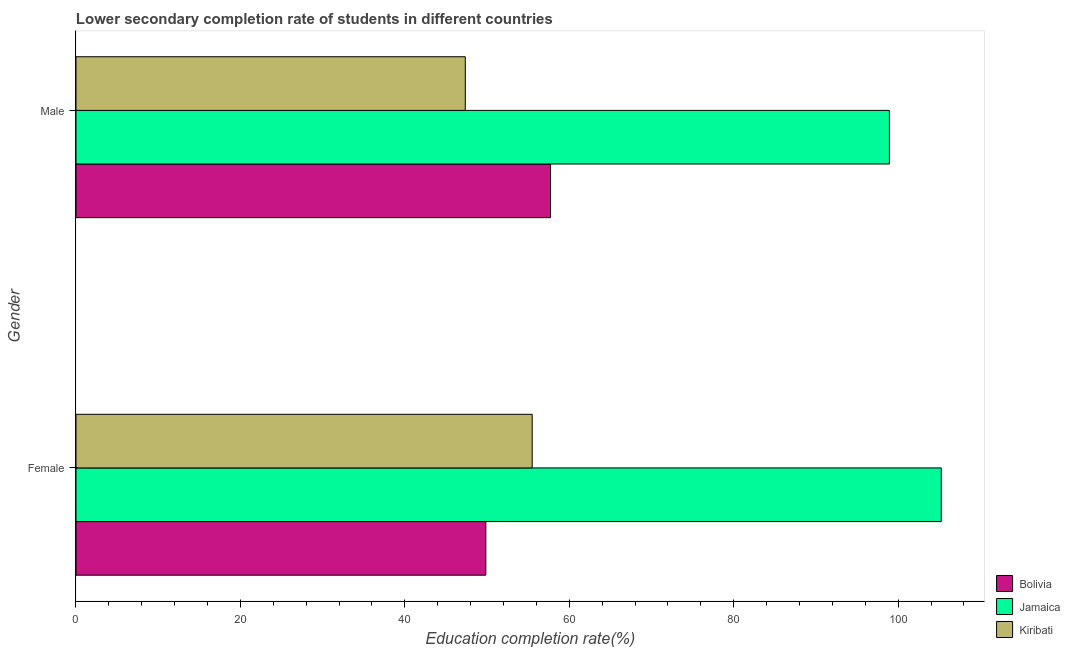How many different coloured bars are there?
Keep it short and to the point. 3. How many groups of bars are there?
Your answer should be very brief. 2. Are the number of bars per tick equal to the number of legend labels?
Your response must be concise. Yes. Are the number of bars on each tick of the Y-axis equal?
Ensure brevity in your answer.  Yes. How many bars are there on the 1st tick from the bottom?
Your answer should be very brief. 3. What is the education completion rate of male students in Kiribati?
Offer a very short reply. 47.35. Across all countries, what is the maximum education completion rate of female students?
Offer a terse response. 105.25. Across all countries, what is the minimum education completion rate of male students?
Give a very brief answer. 47.35. In which country was the education completion rate of male students maximum?
Make the answer very short. Jamaica. What is the total education completion rate of male students in the graph?
Give a very brief answer. 204.01. What is the difference between the education completion rate of male students in Kiribati and that in Bolivia?
Ensure brevity in your answer.  -10.37. What is the difference between the education completion rate of female students in Bolivia and the education completion rate of male students in Kiribati?
Offer a terse response. 2.5. What is the average education completion rate of male students per country?
Your response must be concise. 68. What is the difference between the education completion rate of male students and education completion rate of female students in Kiribati?
Your answer should be compact. -8.14. What is the ratio of the education completion rate of female students in Jamaica to that in Bolivia?
Provide a succinct answer. 2.11. Is the education completion rate of male students in Jamaica less than that in Bolivia?
Your response must be concise. No. In how many countries, is the education completion rate of male students greater than the average education completion rate of male students taken over all countries?
Keep it short and to the point. 1. What does the 1st bar from the bottom in Male represents?
Provide a succinct answer. Bolivia. How many bars are there?
Your answer should be very brief. 6. Are all the bars in the graph horizontal?
Ensure brevity in your answer.  Yes. What is the difference between two consecutive major ticks on the X-axis?
Provide a short and direct response. 20. Are the values on the major ticks of X-axis written in scientific E-notation?
Give a very brief answer. No. Does the graph contain any zero values?
Give a very brief answer. No. Does the graph contain grids?
Ensure brevity in your answer.  No. How many legend labels are there?
Ensure brevity in your answer.  3. What is the title of the graph?
Your response must be concise. Lower secondary completion rate of students in different countries. Does "Tunisia" appear as one of the legend labels in the graph?
Keep it short and to the point. No. What is the label or title of the X-axis?
Offer a very short reply. Education completion rate(%). What is the label or title of the Y-axis?
Your response must be concise. Gender. What is the Education completion rate(%) of Bolivia in Female?
Ensure brevity in your answer.  49.85. What is the Education completion rate(%) of Jamaica in Female?
Offer a terse response. 105.25. What is the Education completion rate(%) in Kiribati in Female?
Provide a succinct answer. 55.49. What is the Education completion rate(%) in Bolivia in Male?
Offer a terse response. 57.72. What is the Education completion rate(%) of Jamaica in Male?
Your answer should be compact. 98.94. What is the Education completion rate(%) in Kiribati in Male?
Make the answer very short. 47.35. Across all Gender, what is the maximum Education completion rate(%) of Bolivia?
Give a very brief answer. 57.72. Across all Gender, what is the maximum Education completion rate(%) in Jamaica?
Give a very brief answer. 105.25. Across all Gender, what is the maximum Education completion rate(%) in Kiribati?
Your answer should be compact. 55.49. Across all Gender, what is the minimum Education completion rate(%) in Bolivia?
Provide a succinct answer. 49.85. Across all Gender, what is the minimum Education completion rate(%) of Jamaica?
Keep it short and to the point. 98.94. Across all Gender, what is the minimum Education completion rate(%) in Kiribati?
Ensure brevity in your answer.  47.35. What is the total Education completion rate(%) in Bolivia in the graph?
Offer a terse response. 107.57. What is the total Education completion rate(%) of Jamaica in the graph?
Your answer should be very brief. 204.19. What is the total Education completion rate(%) in Kiribati in the graph?
Provide a succinct answer. 102.84. What is the difference between the Education completion rate(%) of Bolivia in Female and that in Male?
Offer a very short reply. -7.87. What is the difference between the Education completion rate(%) of Jamaica in Female and that in Male?
Keep it short and to the point. 6.31. What is the difference between the Education completion rate(%) in Kiribati in Female and that in Male?
Give a very brief answer. 8.14. What is the difference between the Education completion rate(%) in Bolivia in Female and the Education completion rate(%) in Jamaica in Male?
Provide a succinct answer. -49.09. What is the difference between the Education completion rate(%) in Bolivia in Female and the Education completion rate(%) in Kiribati in Male?
Your answer should be compact. 2.5. What is the difference between the Education completion rate(%) in Jamaica in Female and the Education completion rate(%) in Kiribati in Male?
Offer a very short reply. 57.9. What is the average Education completion rate(%) in Bolivia per Gender?
Your answer should be very brief. 53.79. What is the average Education completion rate(%) of Jamaica per Gender?
Offer a terse response. 102.09. What is the average Education completion rate(%) in Kiribati per Gender?
Make the answer very short. 51.42. What is the difference between the Education completion rate(%) in Bolivia and Education completion rate(%) in Jamaica in Female?
Keep it short and to the point. -55.4. What is the difference between the Education completion rate(%) of Bolivia and Education completion rate(%) of Kiribati in Female?
Offer a terse response. -5.64. What is the difference between the Education completion rate(%) of Jamaica and Education completion rate(%) of Kiribati in Female?
Offer a very short reply. 49.76. What is the difference between the Education completion rate(%) of Bolivia and Education completion rate(%) of Jamaica in Male?
Make the answer very short. -41.22. What is the difference between the Education completion rate(%) of Bolivia and Education completion rate(%) of Kiribati in Male?
Keep it short and to the point. 10.37. What is the difference between the Education completion rate(%) in Jamaica and Education completion rate(%) in Kiribati in Male?
Make the answer very short. 51.58. What is the ratio of the Education completion rate(%) in Bolivia in Female to that in Male?
Keep it short and to the point. 0.86. What is the ratio of the Education completion rate(%) of Jamaica in Female to that in Male?
Ensure brevity in your answer.  1.06. What is the ratio of the Education completion rate(%) in Kiribati in Female to that in Male?
Your answer should be very brief. 1.17. What is the difference between the highest and the second highest Education completion rate(%) of Bolivia?
Offer a very short reply. 7.87. What is the difference between the highest and the second highest Education completion rate(%) in Jamaica?
Provide a succinct answer. 6.31. What is the difference between the highest and the second highest Education completion rate(%) in Kiribati?
Provide a short and direct response. 8.14. What is the difference between the highest and the lowest Education completion rate(%) in Bolivia?
Give a very brief answer. 7.87. What is the difference between the highest and the lowest Education completion rate(%) in Jamaica?
Give a very brief answer. 6.31. What is the difference between the highest and the lowest Education completion rate(%) of Kiribati?
Provide a succinct answer. 8.14. 